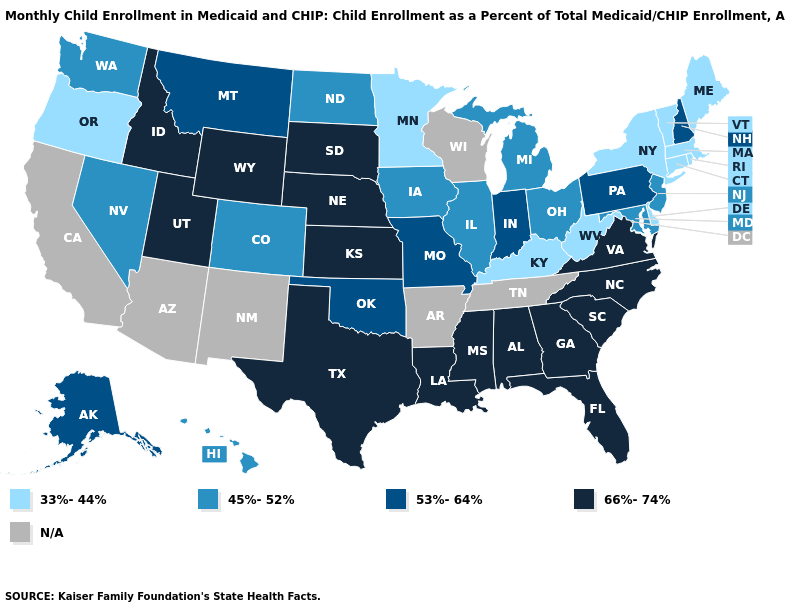Name the states that have a value in the range 53%-64%?
Give a very brief answer. Alaska, Indiana, Missouri, Montana, New Hampshire, Oklahoma, Pennsylvania. What is the value of Idaho?
Quick response, please. 66%-74%. Does the first symbol in the legend represent the smallest category?
Keep it brief. Yes. Which states hav the highest value in the South?
Give a very brief answer. Alabama, Florida, Georgia, Louisiana, Mississippi, North Carolina, South Carolina, Texas, Virginia. Among the states that border Arizona , which have the lowest value?
Quick response, please. Colorado, Nevada. What is the lowest value in the West?
Answer briefly. 33%-44%. What is the value of Utah?
Answer briefly. 66%-74%. Does Oklahoma have the highest value in the USA?
Be succinct. No. Does the map have missing data?
Be succinct. Yes. Does Idaho have the highest value in the USA?
Write a very short answer. Yes. What is the value of Tennessee?
Short answer required. N/A. Does the map have missing data?
Quick response, please. Yes. How many symbols are there in the legend?
Short answer required. 5. 